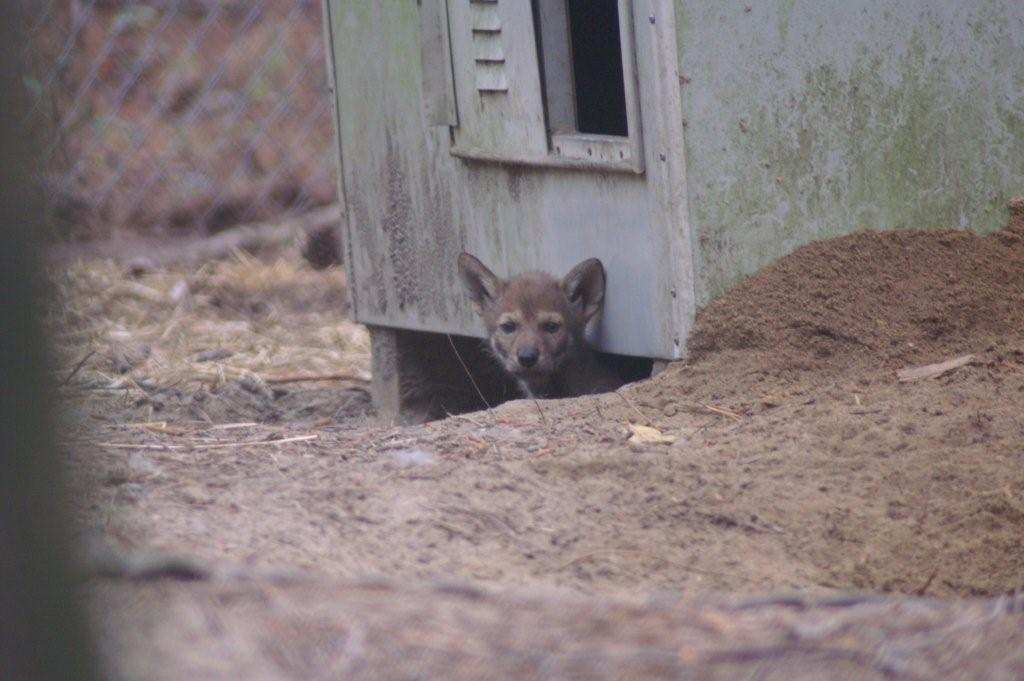What animal can be seen in the image? There is a fox in the image. Where is the fox located in relation to the room or structure? The fox is under a room or structure in the image. What architectural feature is visible in the image? There is a window visible in the image. What can be seen on the left side of the image? There is fencing on the left side of the image. What is the fox's memory like in the image? There is no information about the fox's memory in the image. --- 